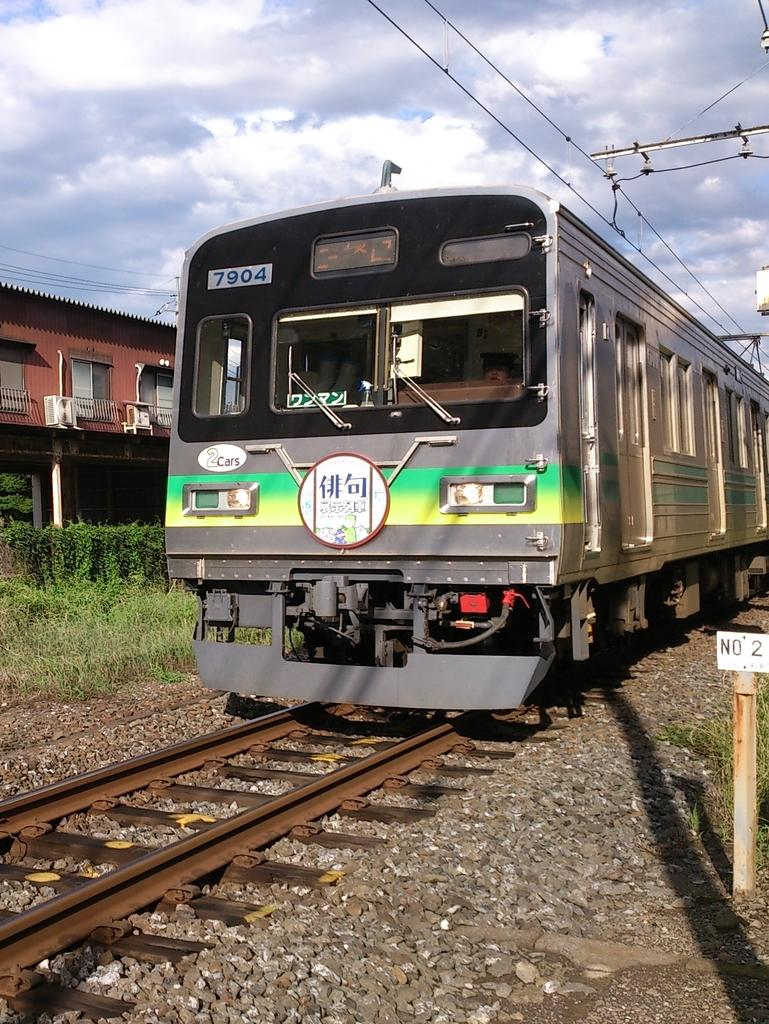What is the main subject of the image? There is a train in the image. Where is the train located? The train is on a track. What type of natural elements can be seen in the image? There are rocks, plants, and grass visible in the image. What type of structure is present in the image? There is a shed in the image. How many ladybugs are crawling on the tray in the image? There is no tray or ladybugs present in the image. What level of difficulty is the train operating at in the image? The image does not provide information about the train's level of difficulty or operation. 